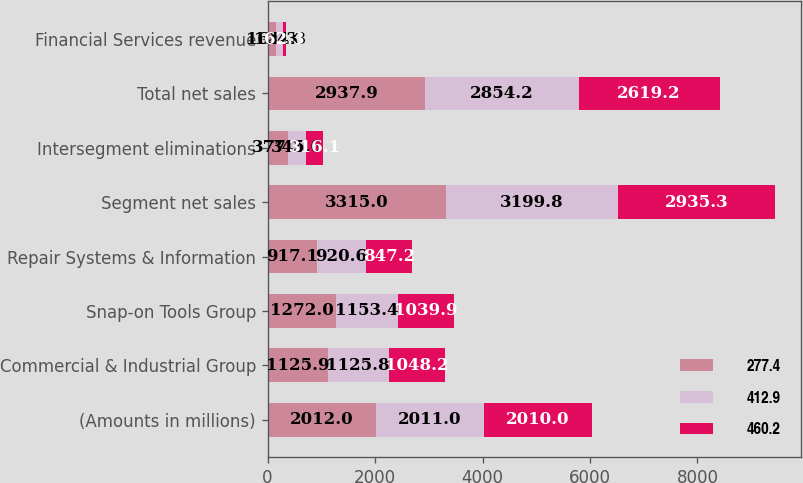Convert chart to OTSL. <chart><loc_0><loc_0><loc_500><loc_500><stacked_bar_chart><ecel><fcel>(Amounts in millions)<fcel>Commercial & Industrial Group<fcel>Snap-on Tools Group<fcel>Repair Systems & Information<fcel>Segment net sales<fcel>Intersegment eliminations<fcel>Total net sales<fcel>Financial Services revenue<nl><fcel>277.4<fcel>2012<fcel>1125.9<fcel>1272<fcel>917.1<fcel>3315<fcel>377.1<fcel>2937.9<fcel>161.3<nl><fcel>412.9<fcel>2011<fcel>1125.8<fcel>1153.4<fcel>920.6<fcel>3199.8<fcel>345.6<fcel>2854.2<fcel>124.3<nl><fcel>460.2<fcel>2010<fcel>1048.2<fcel>1039.9<fcel>847.2<fcel>2935.3<fcel>316.1<fcel>2619.2<fcel>62.3<nl></chart> 